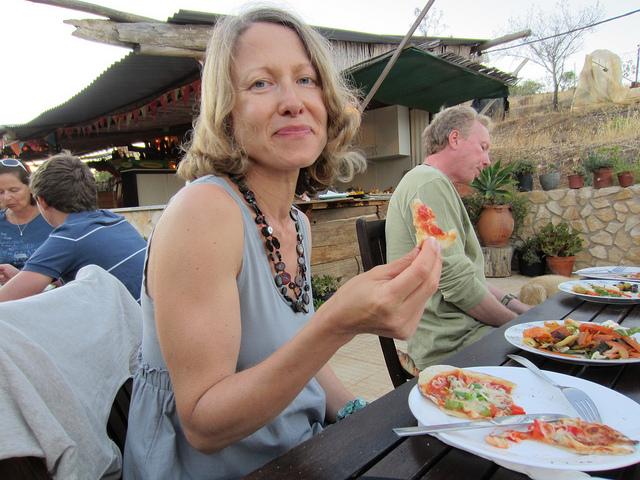How many blue shirts are in the photo?
Be succinct. 2. Would a vegetarian like the meal being served?
Keep it brief. Yes. Are they at a restaurant?
Answer briefly. Yes. Is the woman wearing shades?
Give a very brief answer. No. What color are the girl's fingernails?
Short answer required. Clear. Is the woman upset?
Be succinct. No. 